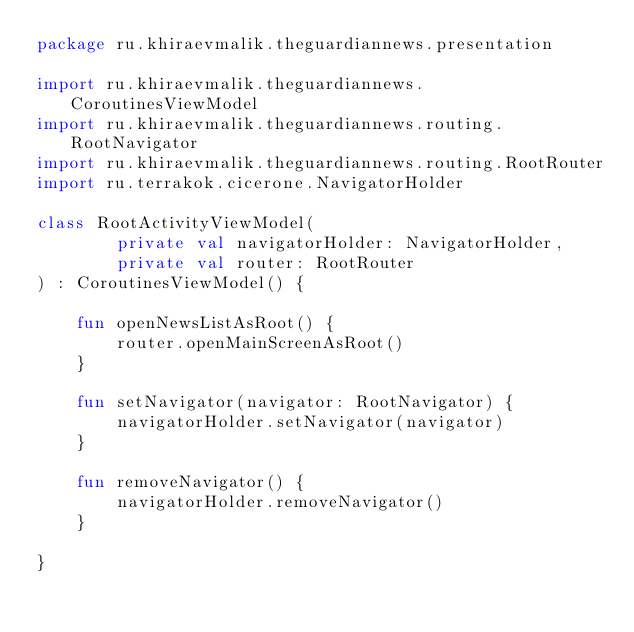<code> <loc_0><loc_0><loc_500><loc_500><_Kotlin_>package ru.khiraevmalik.theguardiannews.presentation

import ru.khiraevmalik.theguardiannews.CoroutinesViewModel
import ru.khiraevmalik.theguardiannews.routing.RootNavigator
import ru.khiraevmalik.theguardiannews.routing.RootRouter
import ru.terrakok.cicerone.NavigatorHolder

class RootActivityViewModel(
        private val navigatorHolder: NavigatorHolder,
        private val router: RootRouter
) : CoroutinesViewModel() {

    fun openNewsListAsRoot() {
        router.openMainScreenAsRoot()
    }

    fun setNavigator(navigator: RootNavigator) {
        navigatorHolder.setNavigator(navigator)
    }

    fun removeNavigator() {
        navigatorHolder.removeNavigator()
    }

}
</code> 